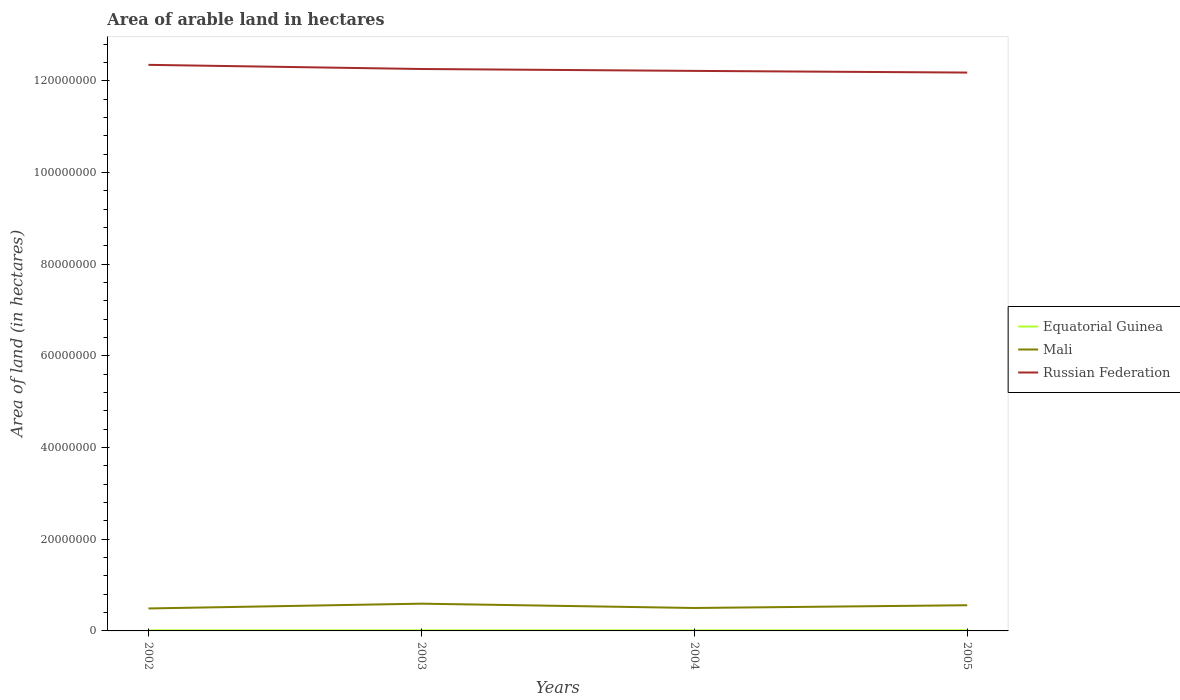Across all years, what is the maximum total arable land in Russian Federation?
Your answer should be very brief. 1.22e+08. In which year was the total arable land in Russian Federation maximum?
Offer a very short reply. 2005. What is the difference between the highest and the second highest total arable land in Russian Federation?
Your answer should be very brief. 1.68e+06. Is the total arable land in Mali strictly greater than the total arable land in Equatorial Guinea over the years?
Provide a short and direct response. No. How many years are there in the graph?
Offer a very short reply. 4. What is the difference between two consecutive major ticks on the Y-axis?
Your answer should be very brief. 2.00e+07. Are the values on the major ticks of Y-axis written in scientific E-notation?
Keep it short and to the point. No. Does the graph contain any zero values?
Give a very brief answer. No. How many legend labels are there?
Your answer should be compact. 3. How are the legend labels stacked?
Keep it short and to the point. Vertical. What is the title of the graph?
Provide a succinct answer. Area of arable land in hectares. What is the label or title of the X-axis?
Make the answer very short. Years. What is the label or title of the Y-axis?
Keep it short and to the point. Area of land (in hectares). What is the Area of land (in hectares) of Mali in 2002?
Keep it short and to the point. 4.90e+06. What is the Area of land (in hectares) of Russian Federation in 2002?
Your answer should be very brief. 1.23e+08. What is the Area of land (in hectares) in Mali in 2003?
Provide a succinct answer. 5.94e+06. What is the Area of land (in hectares) of Russian Federation in 2003?
Offer a terse response. 1.23e+08. What is the Area of land (in hectares) in Equatorial Guinea in 2004?
Ensure brevity in your answer.  1.30e+05. What is the Area of land (in hectares) in Mali in 2004?
Your answer should be compact. 5.00e+06. What is the Area of land (in hectares) in Russian Federation in 2004?
Provide a succinct answer. 1.22e+08. What is the Area of land (in hectares) of Mali in 2005?
Provide a succinct answer. 5.60e+06. What is the Area of land (in hectares) of Russian Federation in 2005?
Offer a terse response. 1.22e+08. Across all years, what is the maximum Area of land (in hectares) of Equatorial Guinea?
Make the answer very short. 1.30e+05. Across all years, what is the maximum Area of land (in hectares) in Mali?
Your response must be concise. 5.94e+06. Across all years, what is the maximum Area of land (in hectares) in Russian Federation?
Give a very brief answer. 1.23e+08. Across all years, what is the minimum Area of land (in hectares) of Mali?
Make the answer very short. 4.90e+06. Across all years, what is the minimum Area of land (in hectares) in Russian Federation?
Offer a very short reply. 1.22e+08. What is the total Area of land (in hectares) in Equatorial Guinea in the graph?
Give a very brief answer. 5.20e+05. What is the total Area of land (in hectares) in Mali in the graph?
Make the answer very short. 2.14e+07. What is the total Area of land (in hectares) of Russian Federation in the graph?
Offer a terse response. 4.90e+08. What is the difference between the Area of land (in hectares) in Equatorial Guinea in 2002 and that in 2003?
Make the answer very short. 0. What is the difference between the Area of land (in hectares) of Mali in 2002 and that in 2003?
Provide a succinct answer. -1.04e+06. What is the difference between the Area of land (in hectares) of Russian Federation in 2002 and that in 2003?
Provide a succinct answer. 9.06e+05. What is the difference between the Area of land (in hectares) in Mali in 2002 and that in 2004?
Give a very brief answer. -1.02e+05. What is the difference between the Area of land (in hectares) in Russian Federation in 2002 and that in 2004?
Make the answer very short. 1.32e+06. What is the difference between the Area of land (in hectares) in Mali in 2002 and that in 2005?
Keep it short and to the point. -7.03e+05. What is the difference between the Area of land (in hectares) in Russian Federation in 2002 and that in 2005?
Keep it short and to the point. 1.68e+06. What is the difference between the Area of land (in hectares) of Mali in 2003 and that in 2004?
Your answer should be compact. 9.40e+05. What is the difference between the Area of land (in hectares) of Russian Federation in 2003 and that in 2004?
Your answer should be very brief. 4.13e+05. What is the difference between the Area of land (in hectares) in Mali in 2003 and that in 2005?
Offer a terse response. 3.39e+05. What is the difference between the Area of land (in hectares) in Russian Federation in 2003 and that in 2005?
Your response must be concise. 7.78e+05. What is the difference between the Area of land (in hectares) in Equatorial Guinea in 2004 and that in 2005?
Give a very brief answer. 0. What is the difference between the Area of land (in hectares) in Mali in 2004 and that in 2005?
Provide a succinct answer. -6.01e+05. What is the difference between the Area of land (in hectares) in Russian Federation in 2004 and that in 2005?
Make the answer very short. 3.65e+05. What is the difference between the Area of land (in hectares) in Equatorial Guinea in 2002 and the Area of land (in hectares) in Mali in 2003?
Give a very brief answer. -5.81e+06. What is the difference between the Area of land (in hectares) of Equatorial Guinea in 2002 and the Area of land (in hectares) of Russian Federation in 2003?
Keep it short and to the point. -1.22e+08. What is the difference between the Area of land (in hectares) of Mali in 2002 and the Area of land (in hectares) of Russian Federation in 2003?
Offer a terse response. -1.18e+08. What is the difference between the Area of land (in hectares) in Equatorial Guinea in 2002 and the Area of land (in hectares) in Mali in 2004?
Ensure brevity in your answer.  -4.87e+06. What is the difference between the Area of land (in hectares) of Equatorial Guinea in 2002 and the Area of land (in hectares) of Russian Federation in 2004?
Provide a succinct answer. -1.22e+08. What is the difference between the Area of land (in hectares) in Mali in 2002 and the Area of land (in hectares) in Russian Federation in 2004?
Your answer should be compact. -1.17e+08. What is the difference between the Area of land (in hectares) in Equatorial Guinea in 2002 and the Area of land (in hectares) in Mali in 2005?
Keep it short and to the point. -5.47e+06. What is the difference between the Area of land (in hectares) in Equatorial Guinea in 2002 and the Area of land (in hectares) in Russian Federation in 2005?
Your response must be concise. -1.22e+08. What is the difference between the Area of land (in hectares) in Mali in 2002 and the Area of land (in hectares) in Russian Federation in 2005?
Make the answer very short. -1.17e+08. What is the difference between the Area of land (in hectares) in Equatorial Guinea in 2003 and the Area of land (in hectares) in Mali in 2004?
Ensure brevity in your answer.  -4.87e+06. What is the difference between the Area of land (in hectares) of Equatorial Guinea in 2003 and the Area of land (in hectares) of Russian Federation in 2004?
Provide a short and direct response. -1.22e+08. What is the difference between the Area of land (in hectares) of Mali in 2003 and the Area of land (in hectares) of Russian Federation in 2004?
Make the answer very short. -1.16e+08. What is the difference between the Area of land (in hectares) in Equatorial Guinea in 2003 and the Area of land (in hectares) in Mali in 2005?
Make the answer very short. -5.47e+06. What is the difference between the Area of land (in hectares) in Equatorial Guinea in 2003 and the Area of land (in hectares) in Russian Federation in 2005?
Make the answer very short. -1.22e+08. What is the difference between the Area of land (in hectares) in Mali in 2003 and the Area of land (in hectares) in Russian Federation in 2005?
Make the answer very short. -1.16e+08. What is the difference between the Area of land (in hectares) of Equatorial Guinea in 2004 and the Area of land (in hectares) of Mali in 2005?
Your answer should be compact. -5.47e+06. What is the difference between the Area of land (in hectares) of Equatorial Guinea in 2004 and the Area of land (in hectares) of Russian Federation in 2005?
Offer a terse response. -1.22e+08. What is the difference between the Area of land (in hectares) in Mali in 2004 and the Area of land (in hectares) in Russian Federation in 2005?
Offer a terse response. -1.17e+08. What is the average Area of land (in hectares) in Mali per year?
Your answer should be compact. 5.36e+06. What is the average Area of land (in hectares) in Russian Federation per year?
Keep it short and to the point. 1.22e+08. In the year 2002, what is the difference between the Area of land (in hectares) in Equatorial Guinea and Area of land (in hectares) in Mali?
Ensure brevity in your answer.  -4.77e+06. In the year 2002, what is the difference between the Area of land (in hectares) in Equatorial Guinea and Area of land (in hectares) in Russian Federation?
Offer a very short reply. -1.23e+08. In the year 2002, what is the difference between the Area of land (in hectares) in Mali and Area of land (in hectares) in Russian Federation?
Make the answer very short. -1.19e+08. In the year 2003, what is the difference between the Area of land (in hectares) in Equatorial Guinea and Area of land (in hectares) in Mali?
Give a very brief answer. -5.81e+06. In the year 2003, what is the difference between the Area of land (in hectares) in Equatorial Guinea and Area of land (in hectares) in Russian Federation?
Provide a short and direct response. -1.22e+08. In the year 2003, what is the difference between the Area of land (in hectares) of Mali and Area of land (in hectares) of Russian Federation?
Your answer should be very brief. -1.17e+08. In the year 2004, what is the difference between the Area of land (in hectares) in Equatorial Guinea and Area of land (in hectares) in Mali?
Offer a very short reply. -4.87e+06. In the year 2004, what is the difference between the Area of land (in hectares) in Equatorial Guinea and Area of land (in hectares) in Russian Federation?
Keep it short and to the point. -1.22e+08. In the year 2004, what is the difference between the Area of land (in hectares) of Mali and Area of land (in hectares) of Russian Federation?
Ensure brevity in your answer.  -1.17e+08. In the year 2005, what is the difference between the Area of land (in hectares) of Equatorial Guinea and Area of land (in hectares) of Mali?
Your response must be concise. -5.47e+06. In the year 2005, what is the difference between the Area of land (in hectares) of Equatorial Guinea and Area of land (in hectares) of Russian Federation?
Offer a very short reply. -1.22e+08. In the year 2005, what is the difference between the Area of land (in hectares) in Mali and Area of land (in hectares) in Russian Federation?
Keep it short and to the point. -1.16e+08. What is the ratio of the Area of land (in hectares) in Equatorial Guinea in 2002 to that in 2003?
Make the answer very short. 1. What is the ratio of the Area of land (in hectares) of Mali in 2002 to that in 2003?
Ensure brevity in your answer.  0.82. What is the ratio of the Area of land (in hectares) in Russian Federation in 2002 to that in 2003?
Offer a terse response. 1.01. What is the ratio of the Area of land (in hectares) in Mali in 2002 to that in 2004?
Your response must be concise. 0.98. What is the ratio of the Area of land (in hectares) of Russian Federation in 2002 to that in 2004?
Your answer should be compact. 1.01. What is the ratio of the Area of land (in hectares) of Equatorial Guinea in 2002 to that in 2005?
Offer a very short reply. 1. What is the ratio of the Area of land (in hectares) in Mali in 2002 to that in 2005?
Offer a very short reply. 0.87. What is the ratio of the Area of land (in hectares) of Russian Federation in 2002 to that in 2005?
Give a very brief answer. 1.01. What is the ratio of the Area of land (in hectares) in Mali in 2003 to that in 2004?
Your answer should be very brief. 1.19. What is the ratio of the Area of land (in hectares) in Russian Federation in 2003 to that in 2004?
Ensure brevity in your answer.  1. What is the ratio of the Area of land (in hectares) in Mali in 2003 to that in 2005?
Make the answer very short. 1.06. What is the ratio of the Area of land (in hectares) in Russian Federation in 2003 to that in 2005?
Offer a terse response. 1.01. What is the ratio of the Area of land (in hectares) in Mali in 2004 to that in 2005?
Make the answer very short. 0.89. What is the difference between the highest and the second highest Area of land (in hectares) of Mali?
Provide a succinct answer. 3.39e+05. What is the difference between the highest and the second highest Area of land (in hectares) in Russian Federation?
Provide a succinct answer. 9.06e+05. What is the difference between the highest and the lowest Area of land (in hectares) in Equatorial Guinea?
Offer a very short reply. 0. What is the difference between the highest and the lowest Area of land (in hectares) in Mali?
Provide a succinct answer. 1.04e+06. What is the difference between the highest and the lowest Area of land (in hectares) of Russian Federation?
Your answer should be compact. 1.68e+06. 